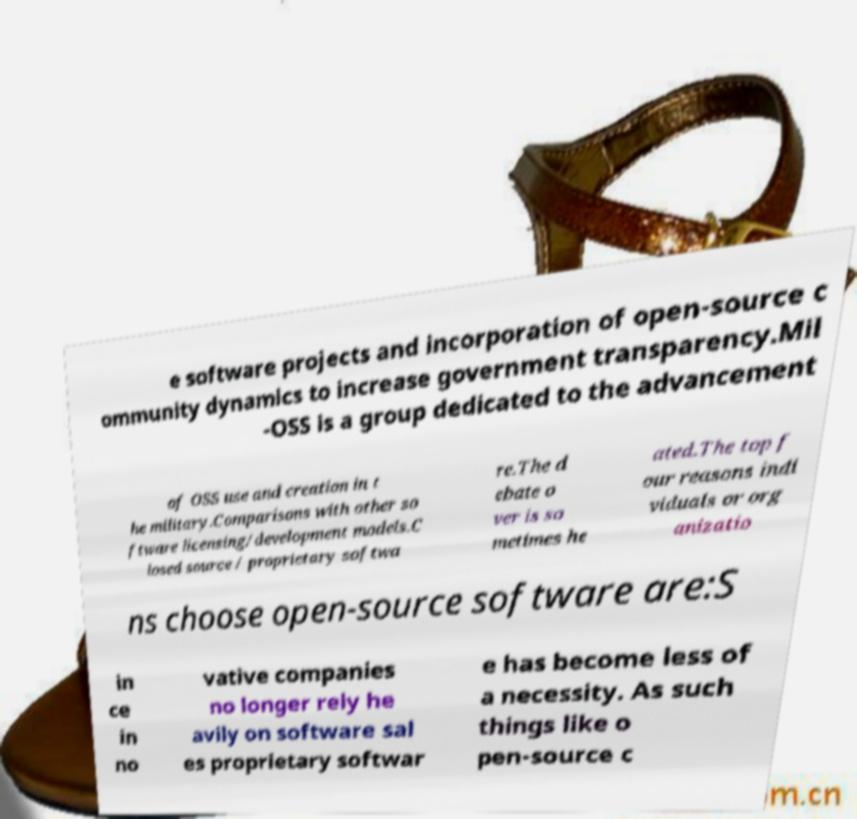Could you extract and type out the text from this image? e software projects and incorporation of open-source c ommunity dynamics to increase government transparency.Mil -OSS is a group dedicated to the advancement of OSS use and creation in t he military.Comparisons with other so ftware licensing/development models.C losed source / proprietary softwa re.The d ebate o ver is so metimes he ated.The top f our reasons indi viduals or org anizatio ns choose open-source software are:S in ce in no vative companies no longer rely he avily on software sal es proprietary softwar e has become less of a necessity. As such things like o pen-source c 